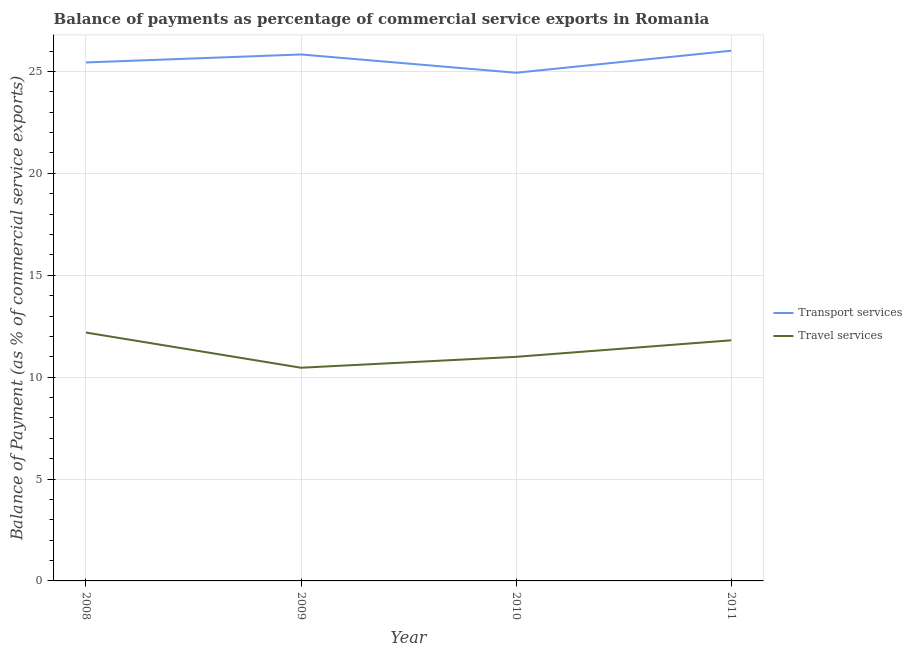Does the line corresponding to balance of payments of travel services intersect with the line corresponding to balance of payments of transport services?
Give a very brief answer. No. Is the number of lines equal to the number of legend labels?
Your answer should be compact. Yes. What is the balance of payments of travel services in 2011?
Offer a terse response. 11.81. Across all years, what is the maximum balance of payments of travel services?
Your answer should be compact. 12.19. Across all years, what is the minimum balance of payments of transport services?
Ensure brevity in your answer.  24.94. In which year was the balance of payments of transport services maximum?
Make the answer very short. 2011. What is the total balance of payments of transport services in the graph?
Make the answer very short. 102.23. What is the difference between the balance of payments of transport services in 2010 and that in 2011?
Give a very brief answer. -1.08. What is the difference between the balance of payments of transport services in 2011 and the balance of payments of travel services in 2009?
Provide a short and direct response. 15.56. What is the average balance of payments of transport services per year?
Provide a succinct answer. 25.56. In the year 2009, what is the difference between the balance of payments of travel services and balance of payments of transport services?
Make the answer very short. -15.37. What is the ratio of the balance of payments of travel services in 2008 to that in 2011?
Offer a terse response. 1.03. Is the balance of payments of travel services in 2009 less than that in 2011?
Provide a short and direct response. Yes. Is the difference between the balance of payments of travel services in 2009 and 2010 greater than the difference between the balance of payments of transport services in 2009 and 2010?
Give a very brief answer. No. What is the difference between the highest and the second highest balance of payments of travel services?
Provide a succinct answer. 0.38. What is the difference between the highest and the lowest balance of payments of transport services?
Keep it short and to the point. 1.08. Does the balance of payments of transport services monotonically increase over the years?
Your response must be concise. No. Is the balance of payments of transport services strictly greater than the balance of payments of travel services over the years?
Provide a succinct answer. Yes. Is the balance of payments of travel services strictly less than the balance of payments of transport services over the years?
Your response must be concise. Yes. How many lines are there?
Your answer should be very brief. 2. How many years are there in the graph?
Give a very brief answer. 4. What is the difference between two consecutive major ticks on the Y-axis?
Your answer should be very brief. 5. Does the graph contain any zero values?
Provide a succinct answer. No. Does the graph contain grids?
Make the answer very short. Yes. How many legend labels are there?
Offer a terse response. 2. How are the legend labels stacked?
Offer a terse response. Vertical. What is the title of the graph?
Your answer should be very brief. Balance of payments as percentage of commercial service exports in Romania. What is the label or title of the Y-axis?
Provide a short and direct response. Balance of Payment (as % of commercial service exports). What is the Balance of Payment (as % of commercial service exports) of Transport services in 2008?
Provide a succinct answer. 25.44. What is the Balance of Payment (as % of commercial service exports) in Travel services in 2008?
Offer a terse response. 12.19. What is the Balance of Payment (as % of commercial service exports) of Transport services in 2009?
Give a very brief answer. 25.83. What is the Balance of Payment (as % of commercial service exports) of Travel services in 2009?
Provide a succinct answer. 10.46. What is the Balance of Payment (as % of commercial service exports) in Transport services in 2010?
Your answer should be compact. 24.94. What is the Balance of Payment (as % of commercial service exports) of Travel services in 2010?
Your answer should be compact. 11. What is the Balance of Payment (as % of commercial service exports) in Transport services in 2011?
Offer a terse response. 26.02. What is the Balance of Payment (as % of commercial service exports) of Travel services in 2011?
Ensure brevity in your answer.  11.81. Across all years, what is the maximum Balance of Payment (as % of commercial service exports) of Transport services?
Keep it short and to the point. 26.02. Across all years, what is the maximum Balance of Payment (as % of commercial service exports) in Travel services?
Give a very brief answer. 12.19. Across all years, what is the minimum Balance of Payment (as % of commercial service exports) of Transport services?
Your answer should be compact. 24.94. Across all years, what is the minimum Balance of Payment (as % of commercial service exports) of Travel services?
Ensure brevity in your answer.  10.46. What is the total Balance of Payment (as % of commercial service exports) in Transport services in the graph?
Provide a short and direct response. 102.23. What is the total Balance of Payment (as % of commercial service exports) in Travel services in the graph?
Offer a terse response. 45.46. What is the difference between the Balance of Payment (as % of commercial service exports) of Transport services in 2008 and that in 2009?
Your response must be concise. -0.39. What is the difference between the Balance of Payment (as % of commercial service exports) in Travel services in 2008 and that in 2009?
Your response must be concise. 1.73. What is the difference between the Balance of Payment (as % of commercial service exports) of Transport services in 2008 and that in 2010?
Offer a terse response. 0.51. What is the difference between the Balance of Payment (as % of commercial service exports) of Travel services in 2008 and that in 2010?
Your answer should be very brief. 1.19. What is the difference between the Balance of Payment (as % of commercial service exports) in Transport services in 2008 and that in 2011?
Your response must be concise. -0.58. What is the difference between the Balance of Payment (as % of commercial service exports) of Travel services in 2008 and that in 2011?
Offer a terse response. 0.38. What is the difference between the Balance of Payment (as % of commercial service exports) of Transport services in 2009 and that in 2010?
Your answer should be very brief. 0.9. What is the difference between the Balance of Payment (as % of commercial service exports) of Travel services in 2009 and that in 2010?
Give a very brief answer. -0.54. What is the difference between the Balance of Payment (as % of commercial service exports) of Transport services in 2009 and that in 2011?
Make the answer very short. -0.18. What is the difference between the Balance of Payment (as % of commercial service exports) in Travel services in 2009 and that in 2011?
Make the answer very short. -1.35. What is the difference between the Balance of Payment (as % of commercial service exports) of Transport services in 2010 and that in 2011?
Your response must be concise. -1.08. What is the difference between the Balance of Payment (as % of commercial service exports) of Travel services in 2010 and that in 2011?
Keep it short and to the point. -0.81. What is the difference between the Balance of Payment (as % of commercial service exports) of Transport services in 2008 and the Balance of Payment (as % of commercial service exports) of Travel services in 2009?
Your response must be concise. 14.98. What is the difference between the Balance of Payment (as % of commercial service exports) in Transport services in 2008 and the Balance of Payment (as % of commercial service exports) in Travel services in 2010?
Make the answer very short. 14.45. What is the difference between the Balance of Payment (as % of commercial service exports) in Transport services in 2008 and the Balance of Payment (as % of commercial service exports) in Travel services in 2011?
Give a very brief answer. 13.63. What is the difference between the Balance of Payment (as % of commercial service exports) in Transport services in 2009 and the Balance of Payment (as % of commercial service exports) in Travel services in 2010?
Make the answer very short. 14.84. What is the difference between the Balance of Payment (as % of commercial service exports) of Transport services in 2009 and the Balance of Payment (as % of commercial service exports) of Travel services in 2011?
Provide a succinct answer. 14.03. What is the difference between the Balance of Payment (as % of commercial service exports) in Transport services in 2010 and the Balance of Payment (as % of commercial service exports) in Travel services in 2011?
Offer a very short reply. 13.13. What is the average Balance of Payment (as % of commercial service exports) in Transport services per year?
Offer a very short reply. 25.56. What is the average Balance of Payment (as % of commercial service exports) of Travel services per year?
Ensure brevity in your answer.  11.36. In the year 2008, what is the difference between the Balance of Payment (as % of commercial service exports) of Transport services and Balance of Payment (as % of commercial service exports) of Travel services?
Make the answer very short. 13.25. In the year 2009, what is the difference between the Balance of Payment (as % of commercial service exports) of Transport services and Balance of Payment (as % of commercial service exports) of Travel services?
Your answer should be compact. 15.37. In the year 2010, what is the difference between the Balance of Payment (as % of commercial service exports) of Transport services and Balance of Payment (as % of commercial service exports) of Travel services?
Give a very brief answer. 13.94. In the year 2011, what is the difference between the Balance of Payment (as % of commercial service exports) of Transport services and Balance of Payment (as % of commercial service exports) of Travel services?
Your response must be concise. 14.21. What is the ratio of the Balance of Payment (as % of commercial service exports) of Travel services in 2008 to that in 2009?
Ensure brevity in your answer.  1.17. What is the ratio of the Balance of Payment (as % of commercial service exports) of Transport services in 2008 to that in 2010?
Your answer should be very brief. 1.02. What is the ratio of the Balance of Payment (as % of commercial service exports) of Travel services in 2008 to that in 2010?
Ensure brevity in your answer.  1.11. What is the ratio of the Balance of Payment (as % of commercial service exports) in Transport services in 2008 to that in 2011?
Ensure brevity in your answer.  0.98. What is the ratio of the Balance of Payment (as % of commercial service exports) of Travel services in 2008 to that in 2011?
Give a very brief answer. 1.03. What is the ratio of the Balance of Payment (as % of commercial service exports) in Transport services in 2009 to that in 2010?
Give a very brief answer. 1.04. What is the ratio of the Balance of Payment (as % of commercial service exports) of Travel services in 2009 to that in 2010?
Make the answer very short. 0.95. What is the ratio of the Balance of Payment (as % of commercial service exports) in Travel services in 2009 to that in 2011?
Ensure brevity in your answer.  0.89. What is the ratio of the Balance of Payment (as % of commercial service exports) in Transport services in 2010 to that in 2011?
Make the answer very short. 0.96. What is the ratio of the Balance of Payment (as % of commercial service exports) in Travel services in 2010 to that in 2011?
Your answer should be compact. 0.93. What is the difference between the highest and the second highest Balance of Payment (as % of commercial service exports) of Transport services?
Offer a very short reply. 0.18. What is the difference between the highest and the second highest Balance of Payment (as % of commercial service exports) of Travel services?
Your answer should be very brief. 0.38. What is the difference between the highest and the lowest Balance of Payment (as % of commercial service exports) in Transport services?
Your answer should be very brief. 1.08. What is the difference between the highest and the lowest Balance of Payment (as % of commercial service exports) of Travel services?
Keep it short and to the point. 1.73. 